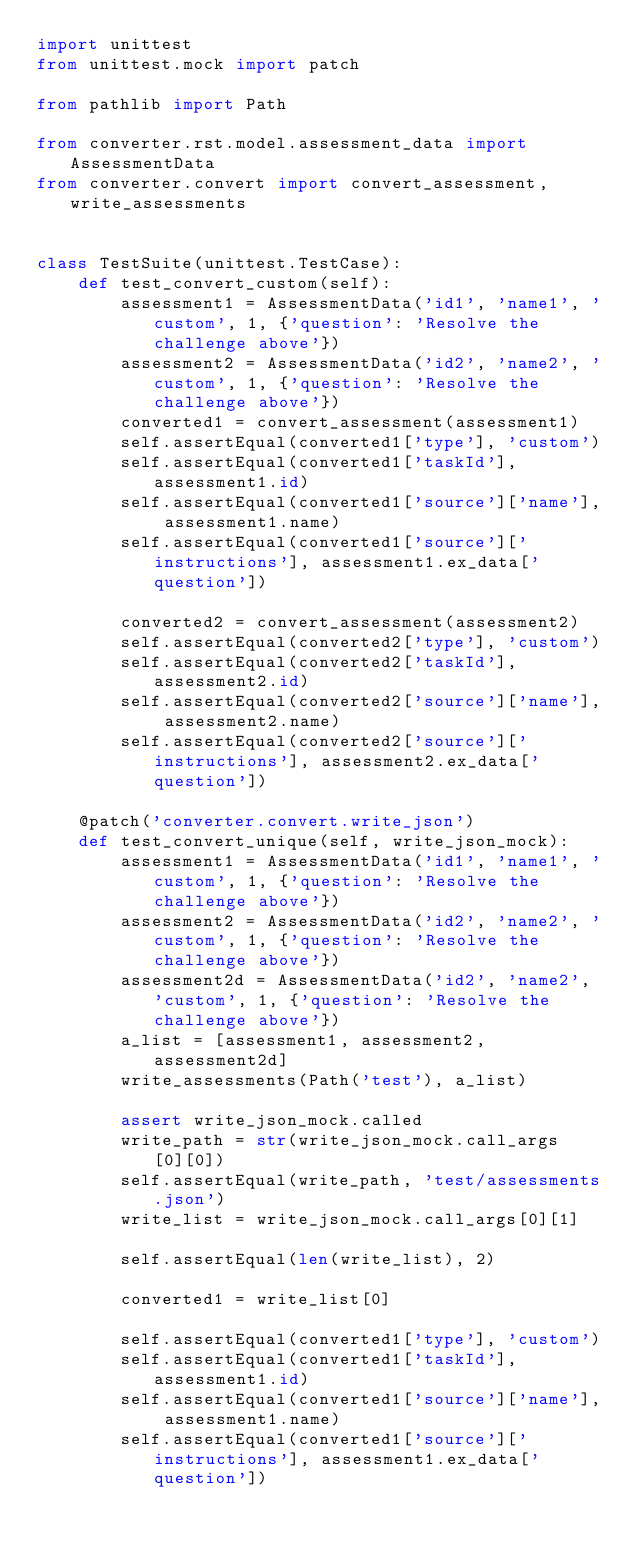<code> <loc_0><loc_0><loc_500><loc_500><_Python_>import unittest
from unittest.mock import patch

from pathlib import Path

from converter.rst.model.assessment_data import AssessmentData
from converter.convert import convert_assessment, write_assessments


class TestSuite(unittest.TestCase):
    def test_convert_custom(self):
        assessment1 = AssessmentData('id1', 'name1', 'custom', 1, {'question': 'Resolve the challenge above'})
        assessment2 = AssessmentData('id2', 'name2', 'custom', 1, {'question': 'Resolve the challenge above'})
        converted1 = convert_assessment(assessment1)
        self.assertEqual(converted1['type'], 'custom')
        self.assertEqual(converted1['taskId'], assessment1.id)
        self.assertEqual(converted1['source']['name'], assessment1.name)
        self.assertEqual(converted1['source']['instructions'], assessment1.ex_data['question'])

        converted2 = convert_assessment(assessment2)
        self.assertEqual(converted2['type'], 'custom')
        self.assertEqual(converted2['taskId'], assessment2.id)
        self.assertEqual(converted2['source']['name'], assessment2.name)
        self.assertEqual(converted2['source']['instructions'], assessment2.ex_data['question'])

    @patch('converter.convert.write_json')
    def test_convert_unique(self, write_json_mock):
        assessment1 = AssessmentData('id1', 'name1', 'custom', 1, {'question': 'Resolve the challenge above'})
        assessment2 = AssessmentData('id2', 'name2', 'custom', 1, {'question': 'Resolve the challenge above'})
        assessment2d = AssessmentData('id2', 'name2', 'custom', 1, {'question': 'Resolve the challenge above'})
        a_list = [assessment1, assessment2, assessment2d]
        write_assessments(Path('test'), a_list)

        assert write_json_mock.called
        write_path = str(write_json_mock.call_args[0][0])
        self.assertEqual(write_path, 'test/assessments.json')
        write_list = write_json_mock.call_args[0][1]

        self.assertEqual(len(write_list), 2)

        converted1 = write_list[0]

        self.assertEqual(converted1['type'], 'custom')
        self.assertEqual(converted1['taskId'], assessment1.id)
        self.assertEqual(converted1['source']['name'], assessment1.name)
        self.assertEqual(converted1['source']['instructions'], assessment1.ex_data['question'])
</code> 